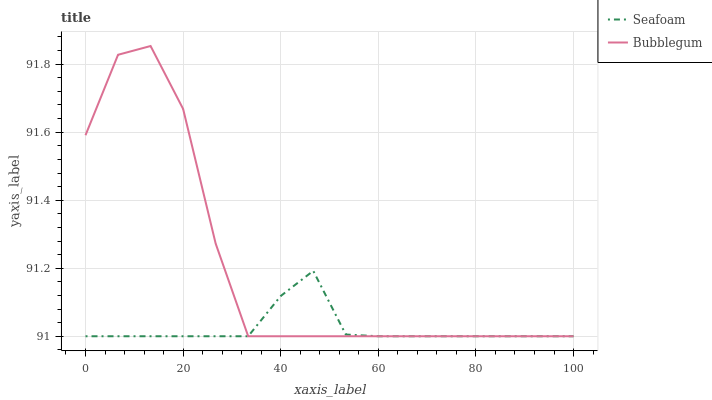Does Seafoam have the minimum area under the curve?
Answer yes or no. Yes. Does Bubblegum have the maximum area under the curve?
Answer yes or no. Yes. Does Bubblegum have the minimum area under the curve?
Answer yes or no. No. Is Seafoam the smoothest?
Answer yes or no. Yes. Is Bubblegum the roughest?
Answer yes or no. Yes. Is Bubblegum the smoothest?
Answer yes or no. No. Does Seafoam have the lowest value?
Answer yes or no. Yes. Does Bubblegum have the highest value?
Answer yes or no. Yes. Does Seafoam intersect Bubblegum?
Answer yes or no. Yes. Is Seafoam less than Bubblegum?
Answer yes or no. No. Is Seafoam greater than Bubblegum?
Answer yes or no. No. 